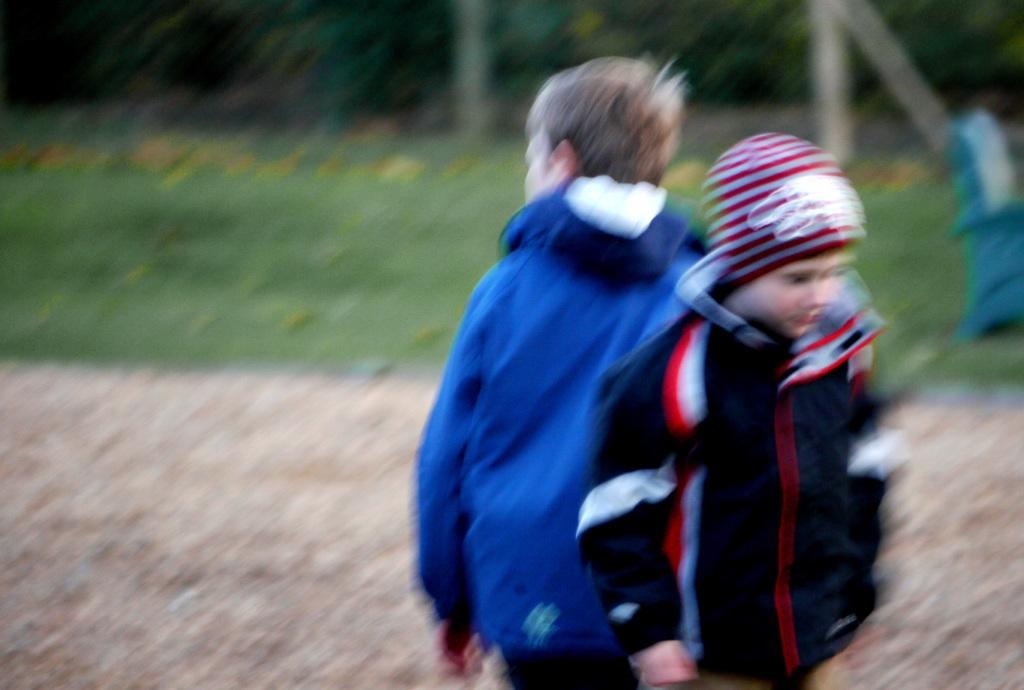How many boys are present in the image? There are two boys in the image. What are the boys doing in the image? The boys are standing on a land. Can you describe the background of the image? The background of the image is blurred. What type of cracker is the boys eating in the image? There is no cracker present in the image, and therefore no such activity can be observed. What badge is the boys wearing in the image? There is no badge visible on the boys in the image. 